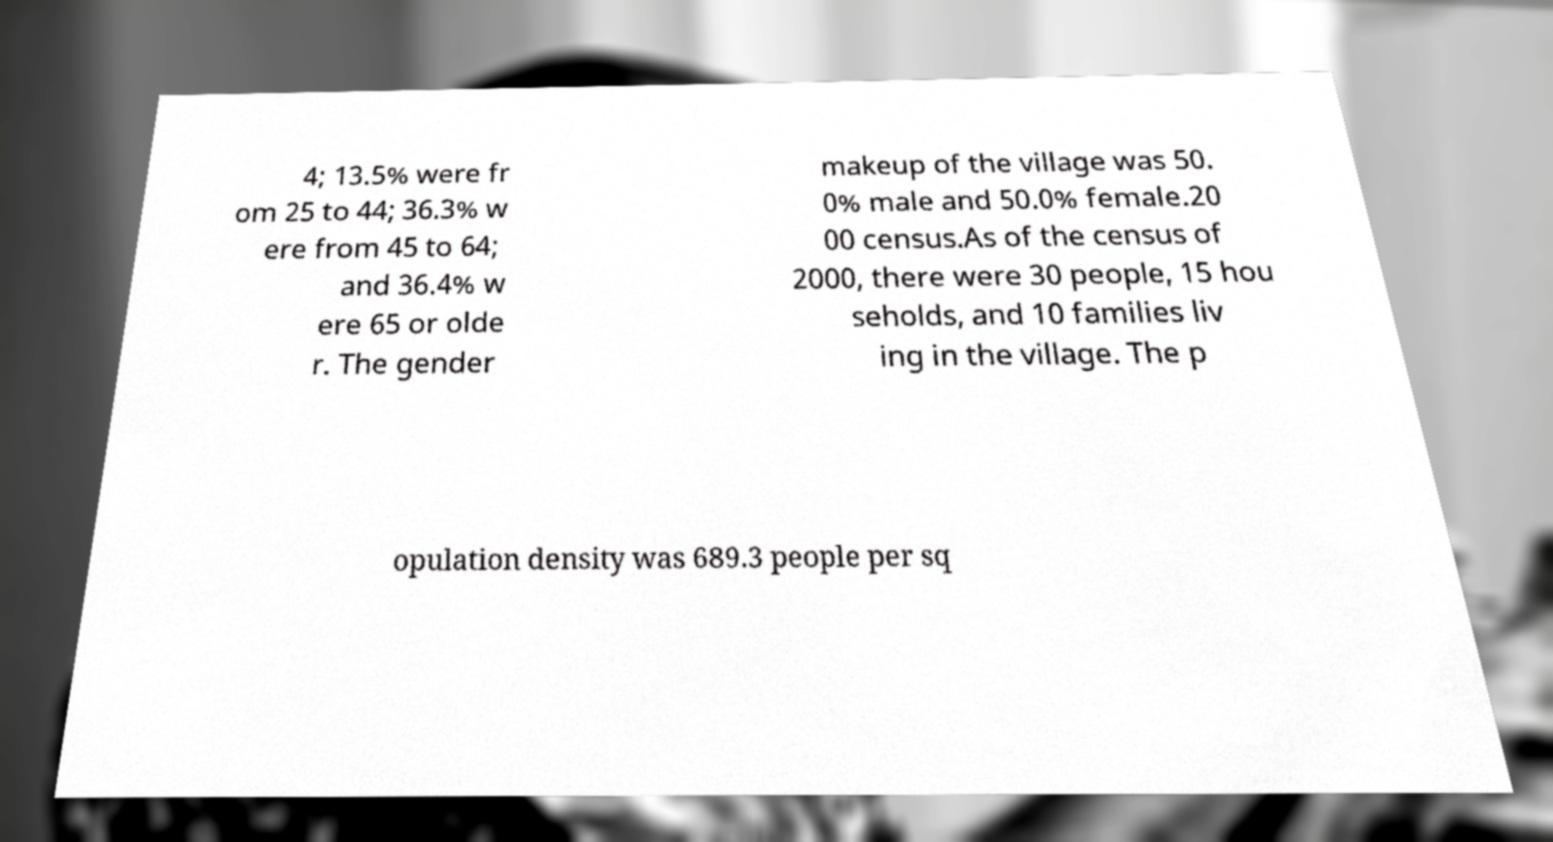Can you accurately transcribe the text from the provided image for me? 4; 13.5% were fr om 25 to 44; 36.3% w ere from 45 to 64; and 36.4% w ere 65 or olde r. The gender makeup of the village was 50. 0% male and 50.0% female.20 00 census.As of the census of 2000, there were 30 people, 15 hou seholds, and 10 families liv ing in the village. The p opulation density was 689.3 people per sq 